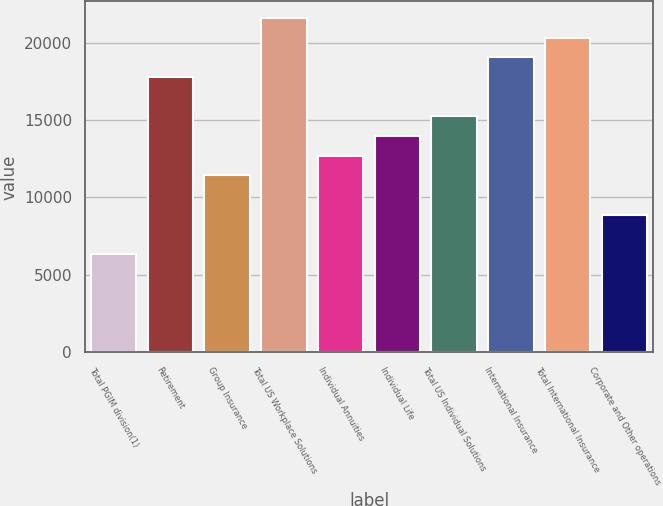Convert chart to OTSL. <chart><loc_0><loc_0><loc_500><loc_500><bar_chart><fcel>Total PGIM division(1)<fcel>Retirement<fcel>Group Insurance<fcel>Total US Workplace Solutions<fcel>Individual Annuities<fcel>Individual Life<fcel>Total US Individual Solutions<fcel>International Insurance<fcel>Total International Insurance<fcel>Corporate and Other operations<nl><fcel>6347.84<fcel>17772.8<fcel>11425.6<fcel>21581.1<fcel>12695<fcel>13964.5<fcel>15233.9<fcel>19042.2<fcel>20311.7<fcel>8886.72<nl></chart> 